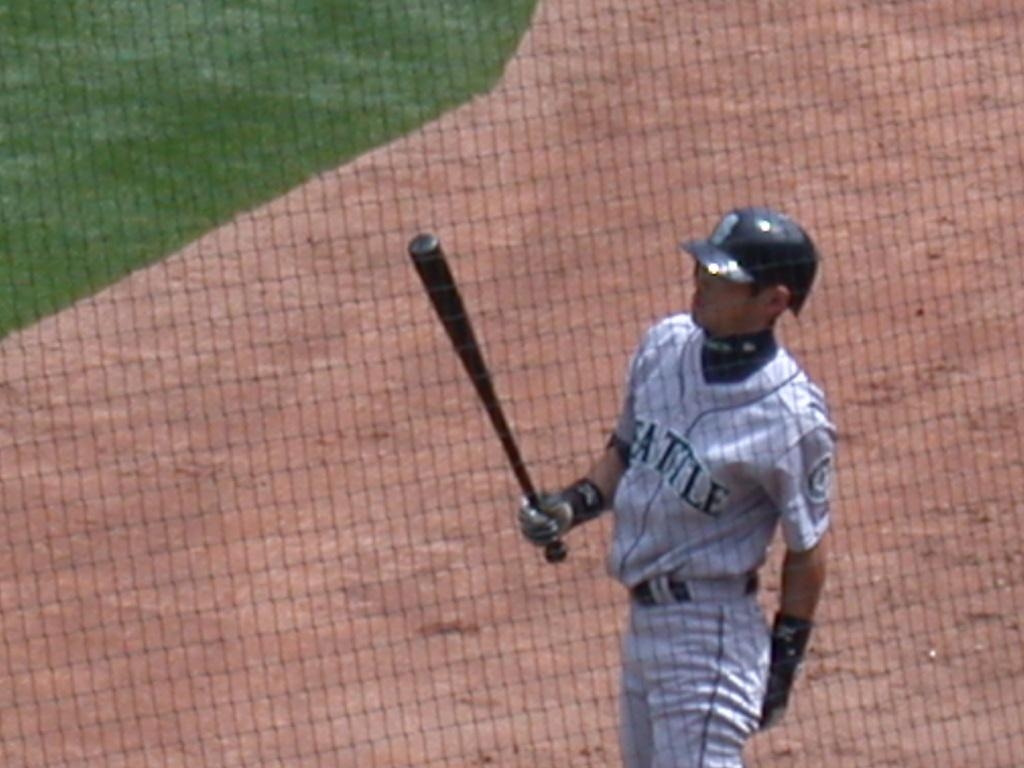What is the man in the image wearing? The man is wearing a white jersey and a helmet. What object is the man holding in the image? The man is holding a baseball bat. What is the man standing in front of in the image? The man is standing in front of a net. What type of surface is visible in the background of the image? There is grassland visible in the background of the image. What type of food is the man eating in the image? There is no food present in the image; the man is holding a baseball bat and standing in front of a net. How does the acoustics of the area affect the man's performance in the image? There is no information about the acoustics of the area in the image, as it focuses on the man, his attire, and the objects he is holding and standing in front of. 